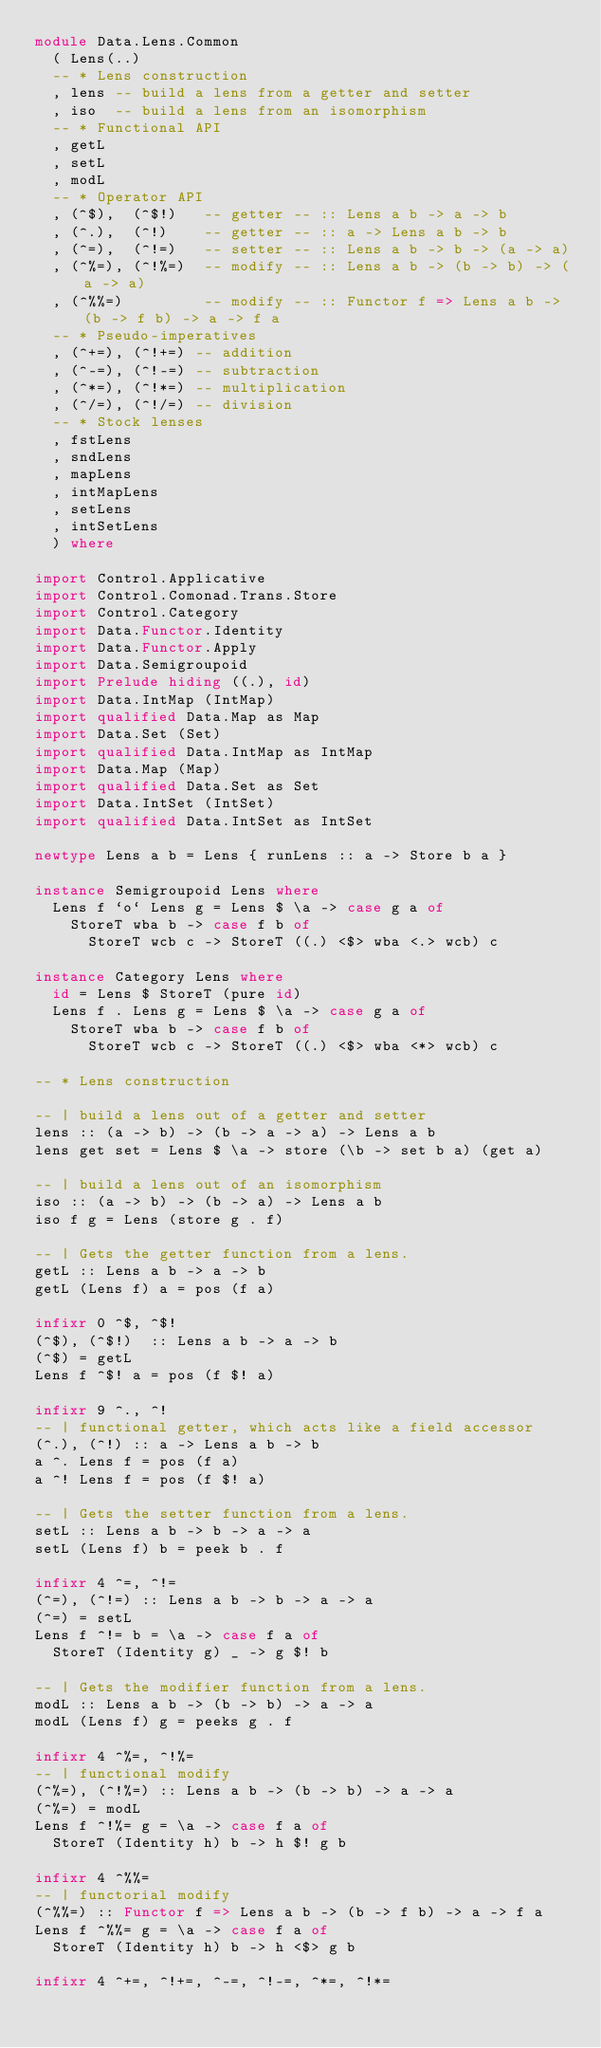Convert code to text. <code><loc_0><loc_0><loc_500><loc_500><_Haskell_>module Data.Lens.Common
  ( Lens(..)
  -- * Lens construction
  , lens -- build a lens from a getter and setter
  , iso  -- build a lens from an isomorphism
  -- * Functional API
  , getL
  , setL
  , modL
  -- * Operator API
  , (^$),  (^$!)   -- getter -- :: Lens a b -> a -> b
  , (^.),  (^!)    -- getter -- :: a -> Lens a b -> b
  , (^=),  (^!=)   -- setter -- :: Lens a b -> b -> (a -> a)
  , (^%=), (^!%=)  -- modify -- :: Lens a b -> (b -> b) -> (a -> a)
  , (^%%=)         -- modify -- :: Functor f => Lens a b -> (b -> f b) -> a -> f a
  -- * Pseudo-imperatives
  , (^+=), (^!+=) -- addition
  , (^-=), (^!-=) -- subtraction
  , (^*=), (^!*=) -- multiplication
  , (^/=), (^!/=) -- division
  -- * Stock lenses
  , fstLens
  , sndLens
  , mapLens
  , intMapLens
  , setLens
  , intSetLens
  ) where

import Control.Applicative
import Control.Comonad.Trans.Store
import Control.Category
import Data.Functor.Identity
import Data.Functor.Apply
import Data.Semigroupoid
import Prelude hiding ((.), id)
import Data.IntMap (IntMap)
import qualified Data.Map as Map
import Data.Set (Set)
import qualified Data.IntMap as IntMap
import Data.Map (Map)
import qualified Data.Set as Set
import Data.IntSet (IntSet)
import qualified Data.IntSet as IntSet

newtype Lens a b = Lens { runLens :: a -> Store b a }

instance Semigroupoid Lens where
  Lens f `o` Lens g = Lens $ \a -> case g a of
    StoreT wba b -> case f b of
      StoreT wcb c -> StoreT ((.) <$> wba <.> wcb) c

instance Category Lens where
  id = Lens $ StoreT (pure id)
  Lens f . Lens g = Lens $ \a -> case g a of
    StoreT wba b -> case f b of
      StoreT wcb c -> StoreT ((.) <$> wba <*> wcb) c

-- * Lens construction

-- | build a lens out of a getter and setter
lens :: (a -> b) -> (b -> a -> a) -> Lens a b
lens get set = Lens $ \a -> store (\b -> set b a) (get a)

-- | build a lens out of an isomorphism
iso :: (a -> b) -> (b -> a) -> Lens a b
iso f g = Lens (store g . f)

-- | Gets the getter function from a lens.
getL :: Lens a b -> a -> b
getL (Lens f) a = pos (f a)

infixr 0 ^$, ^$!
(^$), (^$!)  :: Lens a b -> a -> b
(^$) = getL
Lens f ^$! a = pos (f $! a)

infixr 9 ^., ^!
-- | functional getter, which acts like a field accessor
(^.), (^!) :: a -> Lens a b -> b
a ^. Lens f = pos (f a)
a ^! Lens f = pos (f $! a)

-- | Gets the setter function from a lens.
setL :: Lens a b -> b -> a -> a
setL (Lens f) b = peek b . f

infixr 4 ^=, ^!=
(^=), (^!=) :: Lens a b -> b -> a -> a
(^=) = setL
Lens f ^!= b = \a -> case f a of
  StoreT (Identity g) _ -> g $! b

-- | Gets the modifier function from a lens.
modL :: Lens a b -> (b -> b) -> a -> a
modL (Lens f) g = peeks g . f

infixr 4 ^%=, ^!%=
-- | functional modify
(^%=), (^!%=) :: Lens a b -> (b -> b) -> a -> a
(^%=) = modL
Lens f ^!%= g = \a -> case f a of
  StoreT (Identity h) b -> h $! g b

infixr 4 ^%%=
-- | functorial modify
(^%%=) :: Functor f => Lens a b -> (b -> f b) -> a -> f a
Lens f ^%%= g = \a -> case f a of
  StoreT (Identity h) b -> h <$> g b

infixr 4 ^+=, ^!+=, ^-=, ^!-=, ^*=, ^!*=</code> 